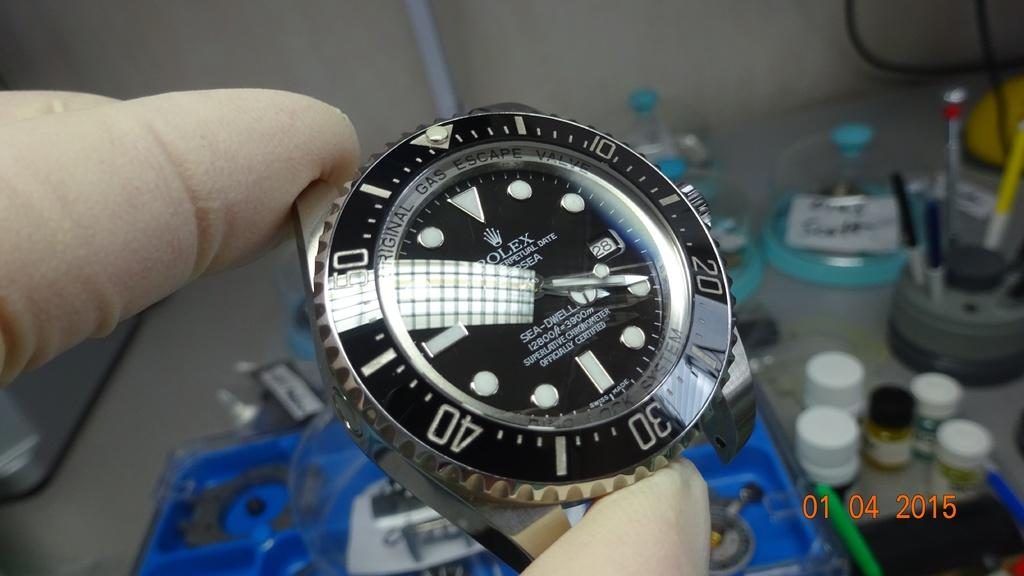<image>
Describe the image concisely. A hand holding the watch face of a Rolex watch. 